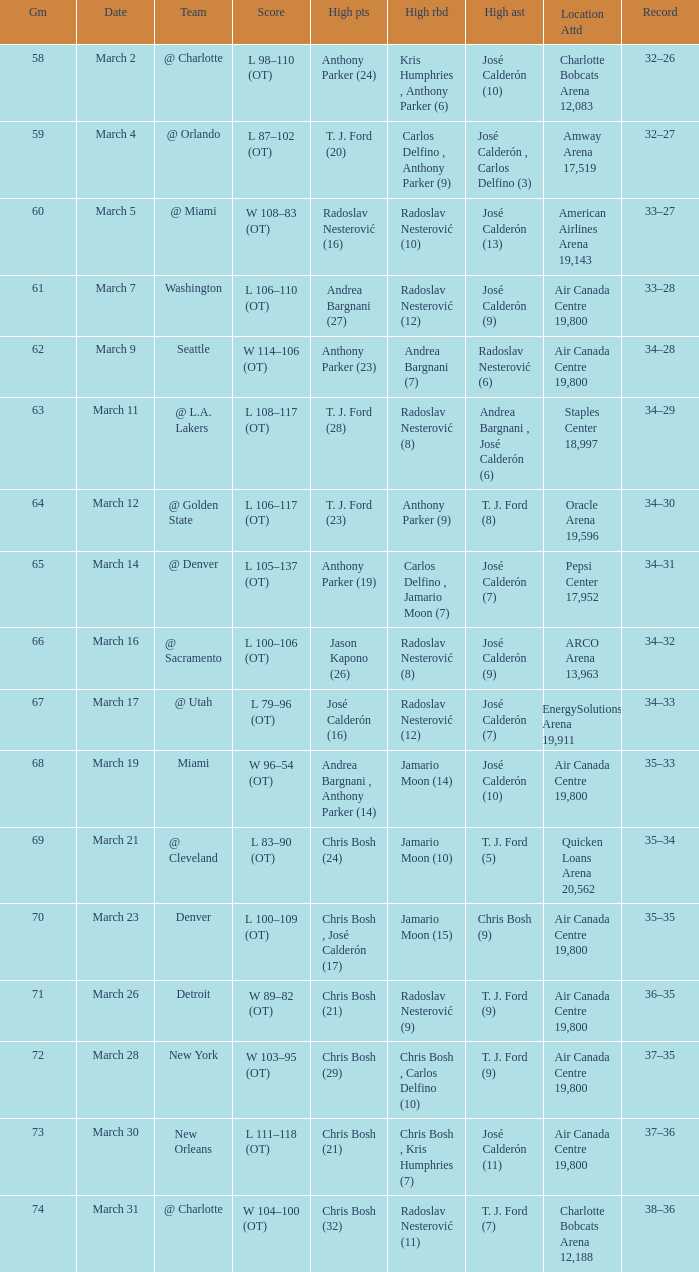What numbered game featured a High rebounds of radoslav nesterović (8), and a High assists of josé calderón (9)? 1.0. Parse the table in full. {'header': ['Gm', 'Date', 'Team', 'Score', 'High pts', 'High rbd', 'High ast', 'Location Attd', 'Record'], 'rows': [['58', 'March 2', '@ Charlotte', 'L 98–110 (OT)', 'Anthony Parker (24)', 'Kris Humphries , Anthony Parker (6)', 'José Calderón (10)', 'Charlotte Bobcats Arena 12,083', '32–26'], ['59', 'March 4', '@ Orlando', 'L 87–102 (OT)', 'T. J. Ford (20)', 'Carlos Delfino , Anthony Parker (9)', 'José Calderón , Carlos Delfino (3)', 'Amway Arena 17,519', '32–27'], ['60', 'March 5', '@ Miami', 'W 108–83 (OT)', 'Radoslav Nesterović (16)', 'Radoslav Nesterović (10)', 'José Calderón (13)', 'American Airlines Arena 19,143', '33–27'], ['61', 'March 7', 'Washington', 'L 106–110 (OT)', 'Andrea Bargnani (27)', 'Radoslav Nesterović (12)', 'José Calderón (9)', 'Air Canada Centre 19,800', '33–28'], ['62', 'March 9', 'Seattle', 'W 114–106 (OT)', 'Anthony Parker (23)', 'Andrea Bargnani (7)', 'Radoslav Nesterović (6)', 'Air Canada Centre 19,800', '34–28'], ['63', 'March 11', '@ L.A. Lakers', 'L 108–117 (OT)', 'T. J. Ford (28)', 'Radoslav Nesterović (8)', 'Andrea Bargnani , José Calderón (6)', 'Staples Center 18,997', '34–29'], ['64', 'March 12', '@ Golden State', 'L 106–117 (OT)', 'T. J. Ford (23)', 'Anthony Parker (9)', 'T. J. Ford (8)', 'Oracle Arena 19,596', '34–30'], ['65', 'March 14', '@ Denver', 'L 105–137 (OT)', 'Anthony Parker (19)', 'Carlos Delfino , Jamario Moon (7)', 'José Calderón (7)', 'Pepsi Center 17,952', '34–31'], ['66', 'March 16', '@ Sacramento', 'L 100–106 (OT)', 'Jason Kapono (26)', 'Radoslav Nesterović (8)', 'José Calderón (9)', 'ARCO Arena 13,963', '34–32'], ['67', 'March 17', '@ Utah', 'L 79–96 (OT)', 'José Calderón (16)', 'Radoslav Nesterović (12)', 'José Calderón (7)', 'EnergySolutions Arena 19,911', '34–33'], ['68', 'March 19', 'Miami', 'W 96–54 (OT)', 'Andrea Bargnani , Anthony Parker (14)', 'Jamario Moon (14)', 'José Calderón (10)', 'Air Canada Centre 19,800', '35–33'], ['69', 'March 21', '@ Cleveland', 'L 83–90 (OT)', 'Chris Bosh (24)', 'Jamario Moon (10)', 'T. J. Ford (5)', 'Quicken Loans Arena 20,562', '35–34'], ['70', 'March 23', 'Denver', 'L 100–109 (OT)', 'Chris Bosh , José Calderón (17)', 'Jamario Moon (15)', 'Chris Bosh (9)', 'Air Canada Centre 19,800', '35–35'], ['71', 'March 26', 'Detroit', 'W 89–82 (OT)', 'Chris Bosh (21)', 'Radoslav Nesterović (9)', 'T. J. Ford (9)', 'Air Canada Centre 19,800', '36–35'], ['72', 'March 28', 'New York', 'W 103–95 (OT)', 'Chris Bosh (29)', 'Chris Bosh , Carlos Delfino (10)', 'T. J. Ford (9)', 'Air Canada Centre 19,800', '37–35'], ['73', 'March 30', 'New Orleans', 'L 111–118 (OT)', 'Chris Bosh (21)', 'Chris Bosh , Kris Humphries (7)', 'José Calderón (11)', 'Air Canada Centre 19,800', '37–36'], ['74', 'March 31', '@ Charlotte', 'W 104–100 (OT)', 'Chris Bosh (32)', 'Radoslav Nesterović (11)', 'T. J. Ford (7)', 'Charlotte Bobcats Arena 12,188', '38–36']]} 